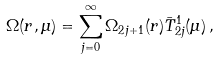Convert formula to latex. <formula><loc_0><loc_0><loc_500><loc_500>\Omega ( r , \mu ) = \sum _ { j = 0 } ^ { \infty } \Omega _ { 2 j + 1 } ( r ) \bar { T } ^ { 1 } _ { 2 j } ( \mu ) \, ,</formula> 